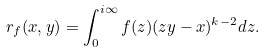<formula> <loc_0><loc_0><loc_500><loc_500>r _ { f } ( x , y ) = \int _ { 0 } ^ { i \infty } f ( z ) ( z y - x ) ^ { k - 2 } d z .</formula> 